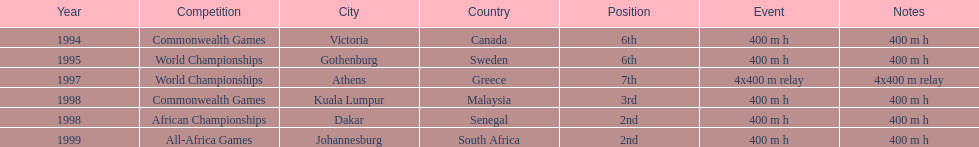What years did ken harder compete in? 1994, 1995, 1997, 1998, 1998, 1999. For the 1997 relay, what distance was ran? 4x400 m relay. 